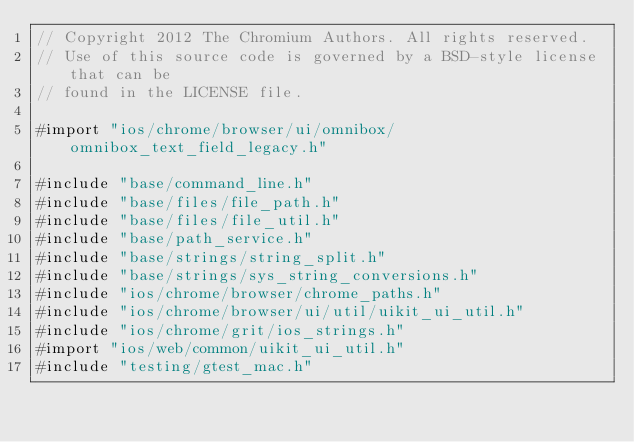<code> <loc_0><loc_0><loc_500><loc_500><_ObjectiveC_>// Copyright 2012 The Chromium Authors. All rights reserved.
// Use of this source code is governed by a BSD-style license that can be
// found in the LICENSE file.

#import "ios/chrome/browser/ui/omnibox/omnibox_text_field_legacy.h"

#include "base/command_line.h"
#include "base/files/file_path.h"
#include "base/files/file_util.h"
#include "base/path_service.h"
#include "base/strings/string_split.h"
#include "base/strings/sys_string_conversions.h"
#include "ios/chrome/browser/chrome_paths.h"
#include "ios/chrome/browser/ui/util/uikit_ui_util.h"
#include "ios/chrome/grit/ios_strings.h"
#import "ios/web/common/uikit_ui_util.h"
#include "testing/gtest_mac.h"</code> 